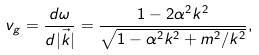Convert formula to latex. <formula><loc_0><loc_0><loc_500><loc_500>v _ { g } = \frac { d \omega } { d | \vec { k } | } = \frac { 1 - 2 \alpha ^ { 2 } k ^ { 2 } } { \sqrt { 1 - \alpha ^ { 2 } k ^ { 2 } + m ^ { 2 } / k ^ { 2 } } } ,</formula> 